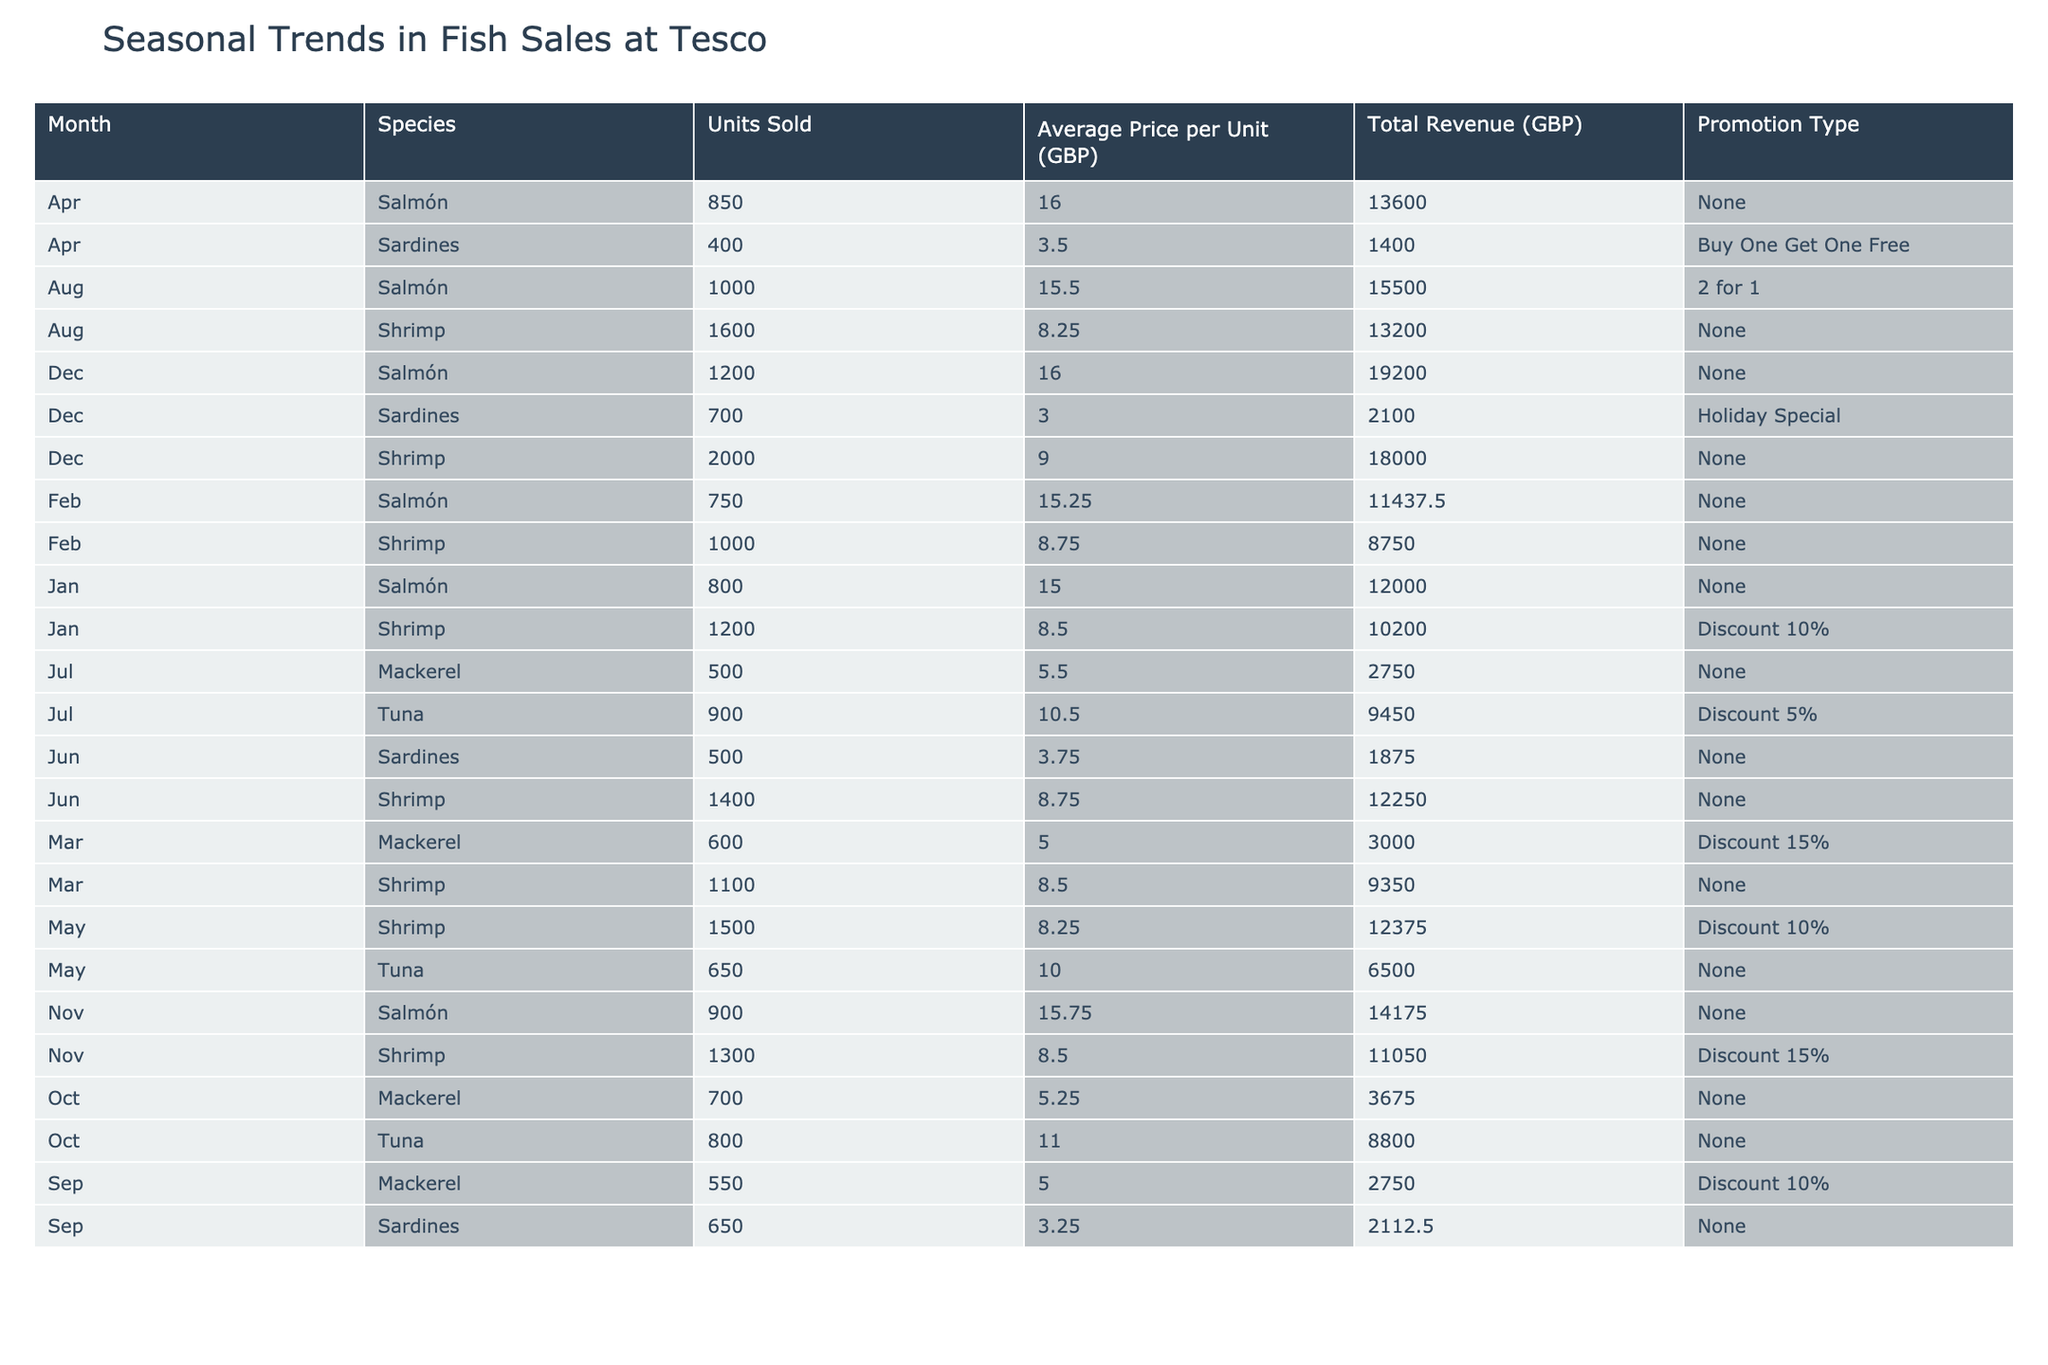What species sold the most units in December? In December, looking at the "Units Sold" column, Shrimp has the highest number with 2000 units sold.
Answer: Shrimp Was there any month when Mackerel was sold at a lower price than 5 GBP per unit? Yes, in March, Mackerel was sold at 5 GBP per unit, which is not lower than 5 GBP, but September had a price of 5 GBP too. Thus, no month had a price lower than 5 GBP for Mackerel.
Answer: No What was the total revenue from Salmon sales in November? In November, Salmon had 900 units sold, each priced at 15.75 GBP, so the total revenue is calculated as 900 * 15.75 = 14175 GBP.
Answer: 14175 GBP Which month had the highest sales for Shrimp and what was the total revenue for that month? The highest sales for Shrimp occurred in December with 2000 units sold. The total revenue for that month was calculated as 2000 * 9.00 = 18000 GBP.
Answer: December, 18000 GBP What was the average price per unit for Tuna sold throughout the year? Tuna was sold in three months: May at 10.00 GBP, July at 10.50 GBP, and October at 11.00 GBP. The total for these is 10.00 + 10.50 + 11.00 = 31.50 GBP; dividing by 3 gives an average price of 31.50 / 3 = 10.50 GBP.
Answer: 10.50 GBP How many units of Sardines were sold in total across all months? The total units of Sardines sold can be computed by adding the numbers: April (400) + June (500) + September (650) + December (700) = 400 + 500 + 650 + 700 = 2250 units sold in total.
Answer: 2250 units Was there a month without any price promotions and sales for Salmon? Observing the table, there are several months where Salmon was sold with no promotions: January, February, April, November, and October. Thus, it is true that there were months without promotions.
Answer: Yes How many different species were sold in August and what were their total units sold? In August, two species were sold: Salmon (1000 units) and Shrimp (1600 units). The total units sold are 1000 + 1600 = 2600 units.
Answer: 2 species, 2600 units What was the month with the most units sold for any species, and what were those total units? The month with the most units sold for any species was December with Shrimp at 2000 units, making it the highest sales figure for any month.
Answer: December, 2000 units 